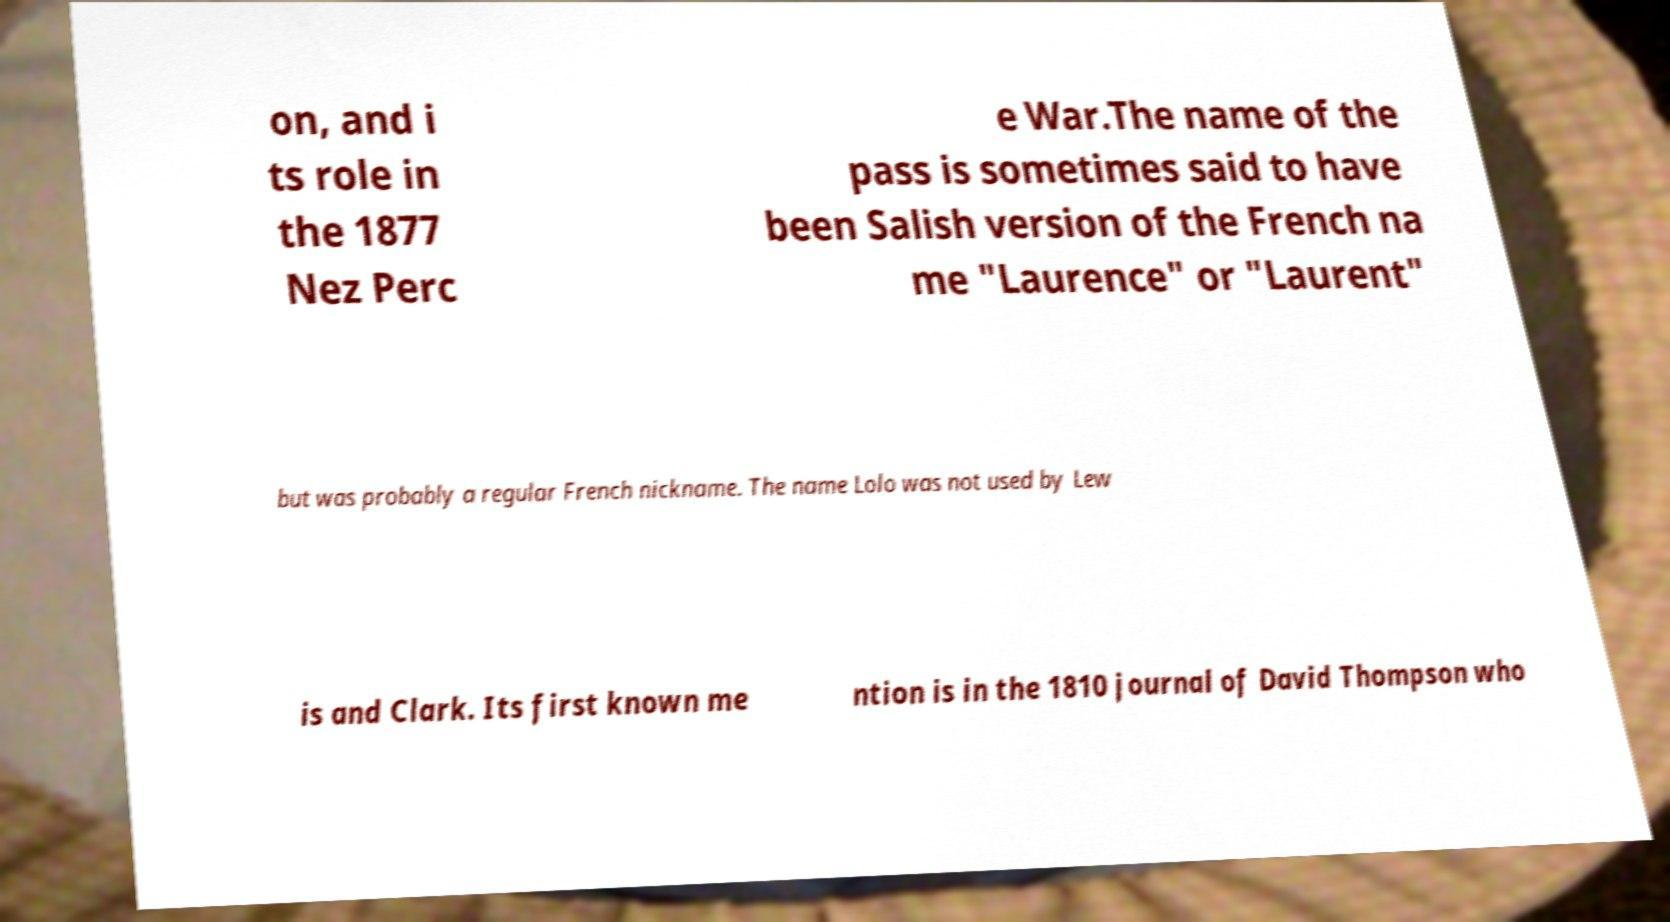Could you extract and type out the text from this image? on, and i ts role in the 1877 Nez Perc e War.The name of the pass is sometimes said to have been Salish version of the French na me "Laurence" or "Laurent" but was probably a regular French nickname. The name Lolo was not used by Lew is and Clark. Its first known me ntion is in the 1810 journal of David Thompson who 